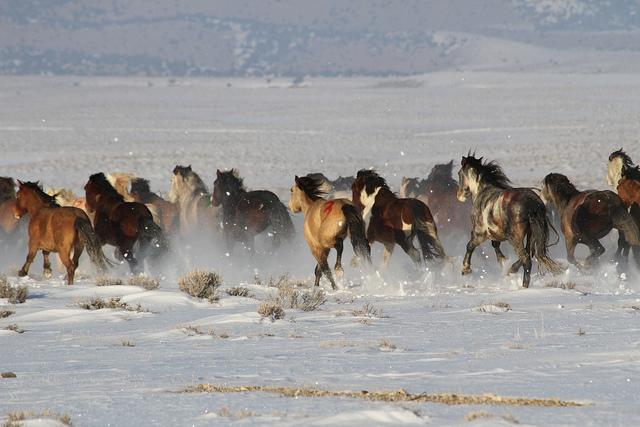Is there snow on the ground?
Be succinct. Yes. Are the horses cold?
Keep it brief. Yes. Are these animals good for taming?
Concise answer only. Yes. 